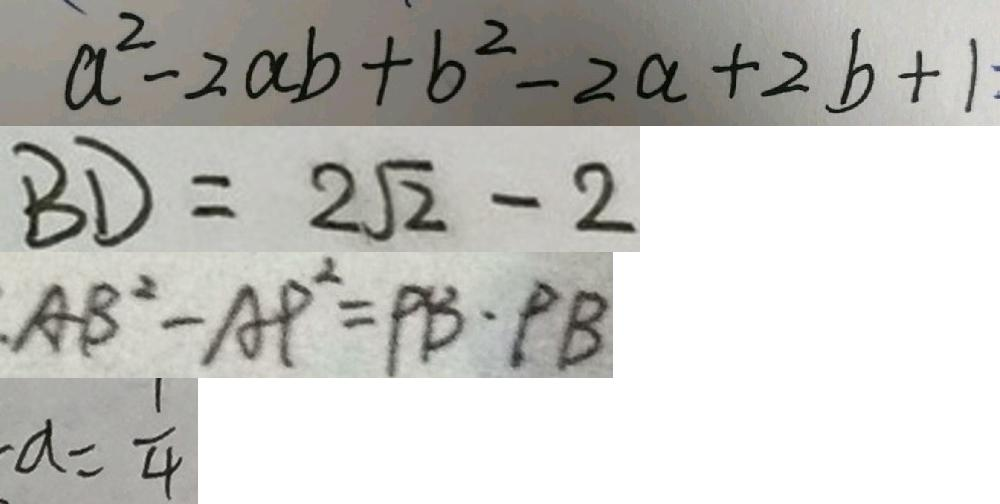<formula> <loc_0><loc_0><loc_500><loc_500>a ^ { 2 } - 2 a b + b ^ { 2 } - 2 a + 2 b + 1 
 B D = 2 \sqrt { 2 } - 2 
 A B ^ { 2 } - A P ^ { 2 } = P B \cdot P B 
 a = \frac { 1 } { 4 }</formula> 